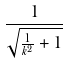<formula> <loc_0><loc_0><loc_500><loc_500>\frac { 1 } { \sqrt { \frac { 1 } { k ^ { 2 } } + 1 } }</formula> 